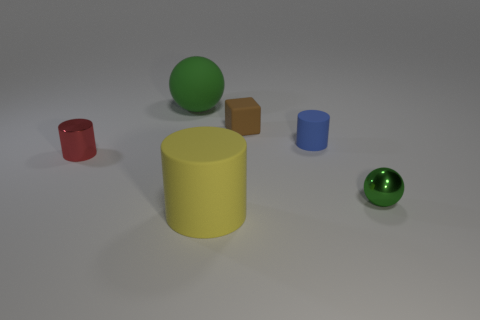Add 4 large green matte balls. How many objects exist? 10 Subtract all cubes. How many objects are left? 5 Add 2 tiny red metal things. How many tiny red metal things exist? 3 Subtract 0 brown balls. How many objects are left? 6 Subtract all large things. Subtract all green things. How many objects are left? 2 Add 4 big yellow objects. How many big yellow objects are left? 5 